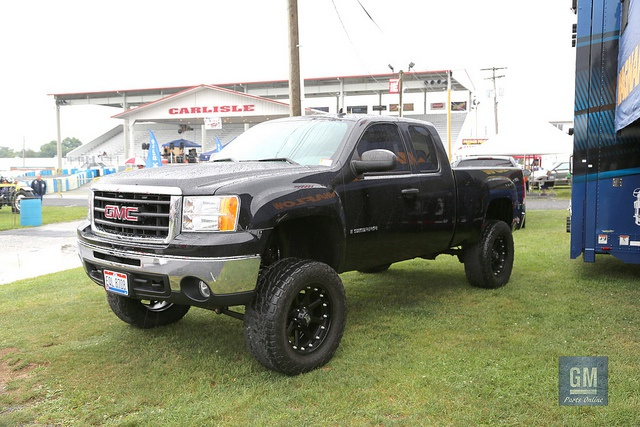Describe the objects in this image and their specific colors. I can see truck in white, black, gray, and darkgray tones, car in white, darkgray, gray, and black tones, and people in white, gray, lightgray, and darkgray tones in this image. 